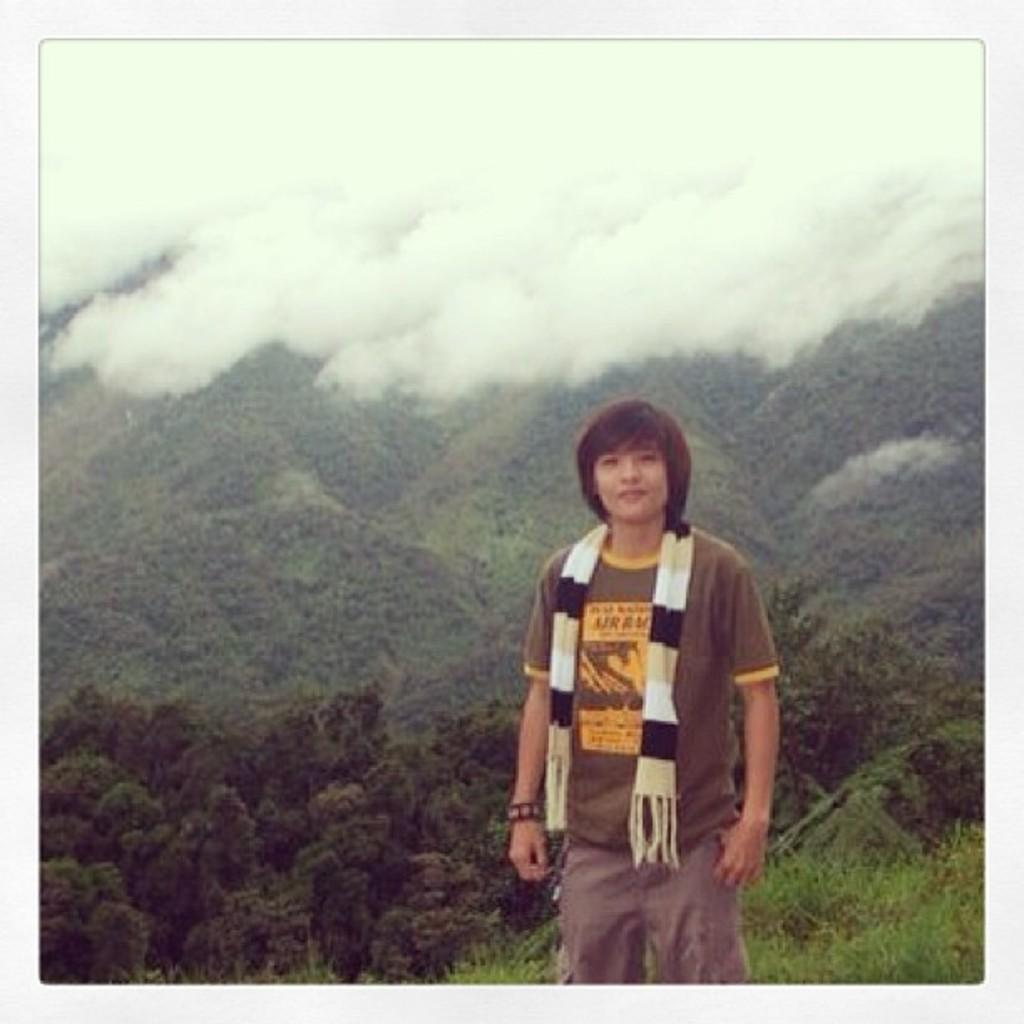What is the main subject of the image? There is a person standing in the image. What type of terrain is visible in the image? There is grass, trees, and hills visible in the image. What is visible in the background of the image? The sky is visible in the image. What type of shoes is the insect wearing in the image? There is no insect present in the image, and therefore no shoes can be observed. What company is responsible for the hills in the image? The image does not provide information about the company responsible for the hills. 